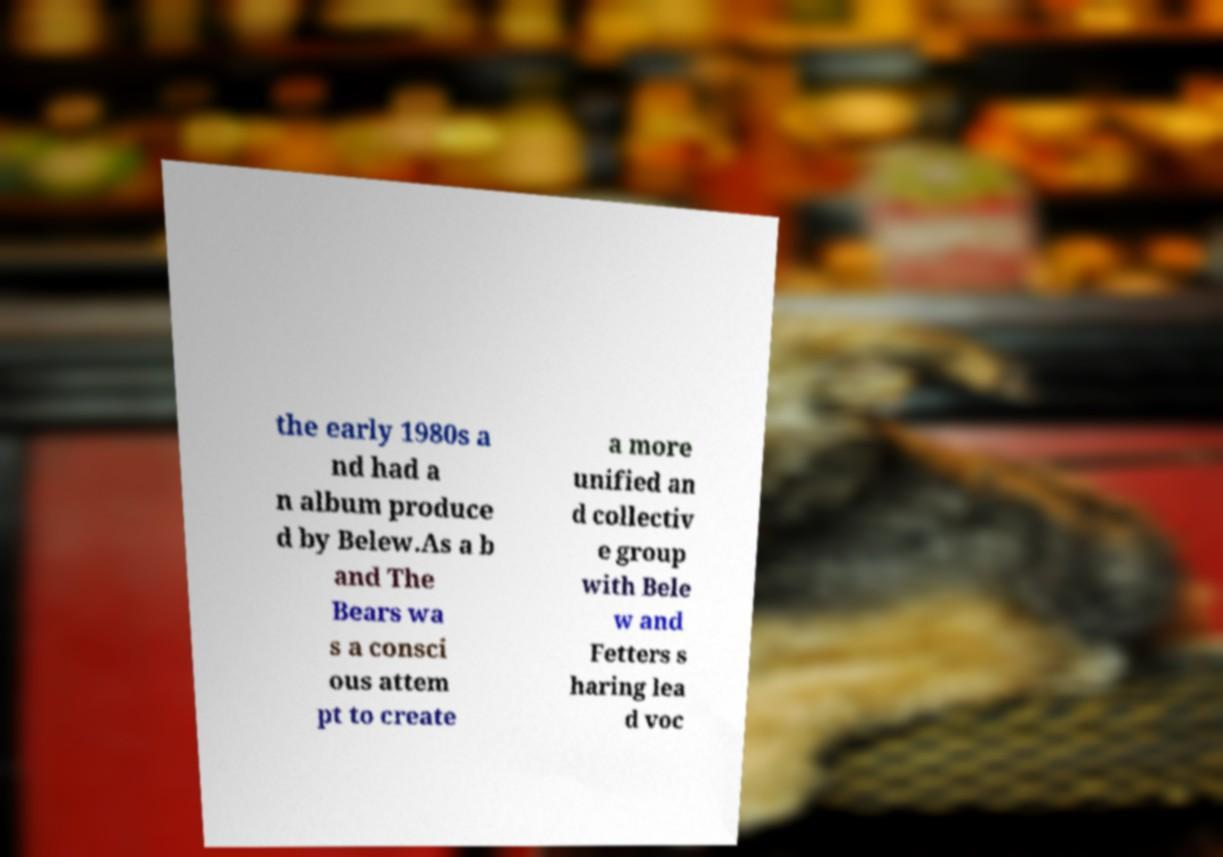Please identify and transcribe the text found in this image. the early 1980s a nd had a n album produce d by Belew.As a b and The Bears wa s a consci ous attem pt to create a more unified an d collectiv e group with Bele w and Fetters s haring lea d voc 